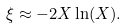<formula> <loc_0><loc_0><loc_500><loc_500>\xi \approx - 2 X \ln ( X ) .</formula> 